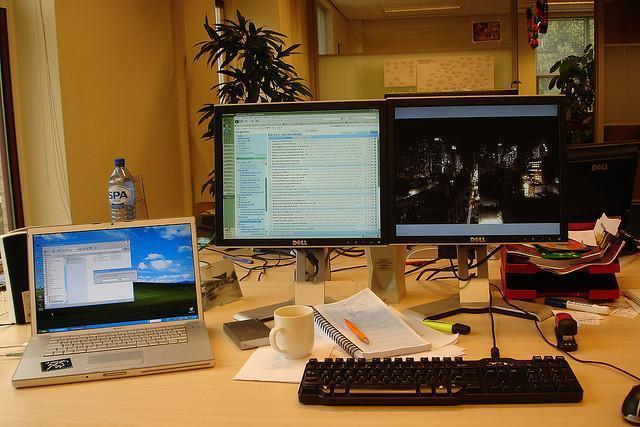How many potted plants can be seen?
Give a very brief answer. 2. How many tvs can be seen?
Give a very brief answer. 2. How many keyboards can you see?
Give a very brief answer. 1. 